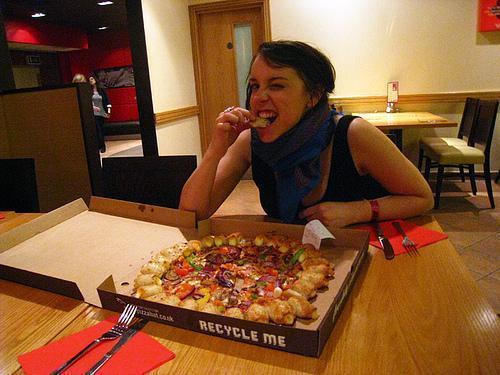How many utensils are there on the table?
Give a very brief answer. 2. 